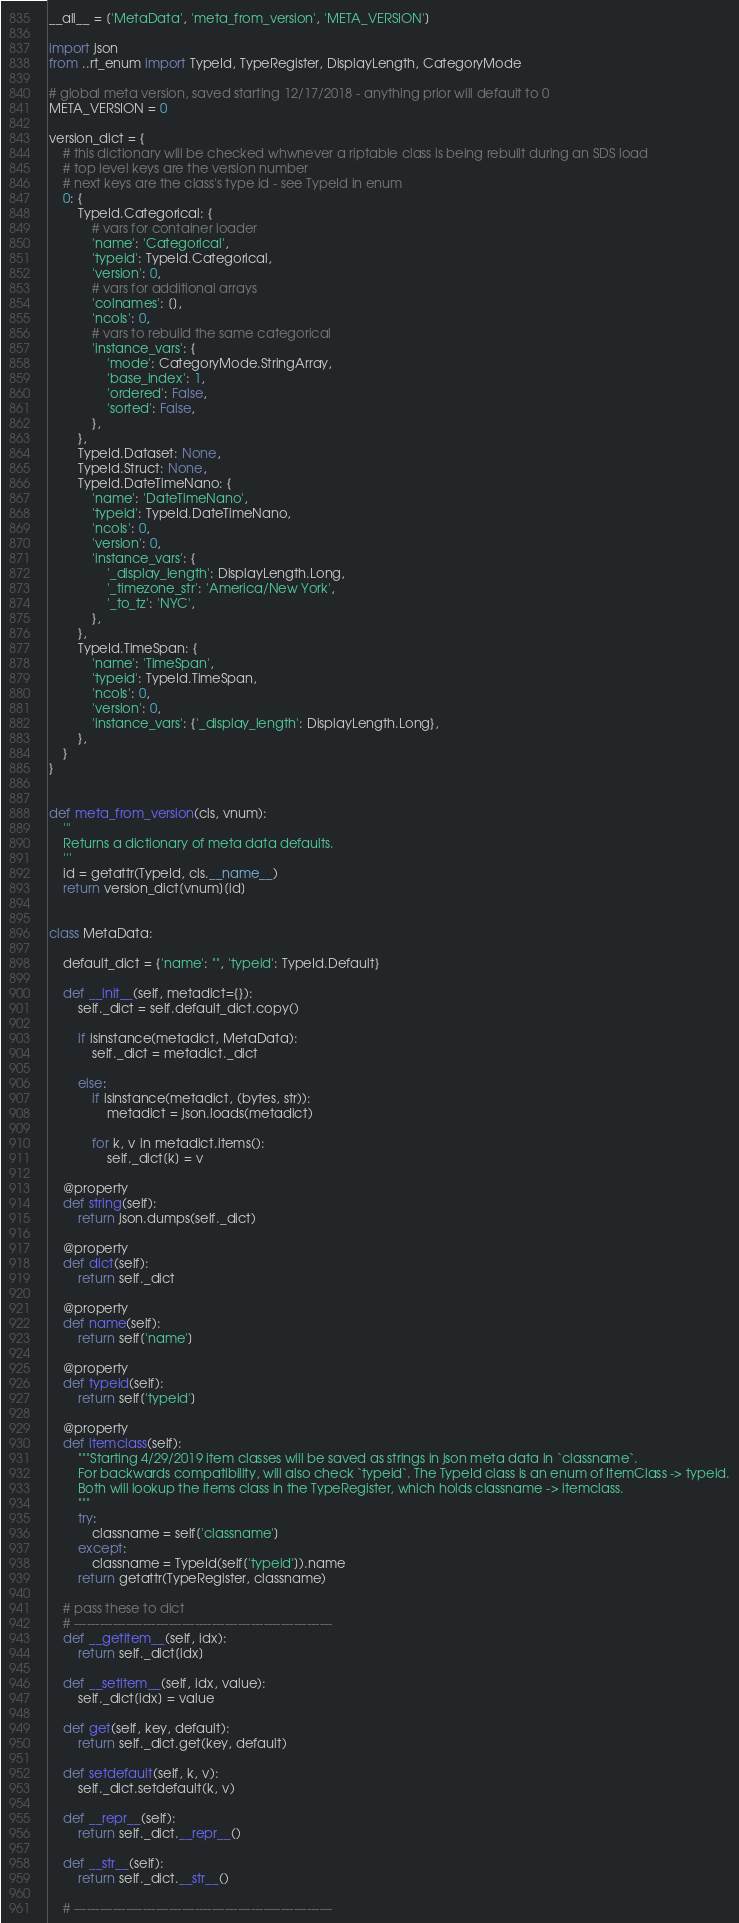<code> <loc_0><loc_0><loc_500><loc_500><_Python_>__all__ = ['MetaData', 'meta_from_version', 'META_VERSION']

import json
from ..rt_enum import TypeId, TypeRegister, DisplayLength, CategoryMode

# global meta version, saved starting 12/17/2018 - anything prior will default to 0
META_VERSION = 0

version_dict = {
    # this dictionary will be checked whwnever a riptable class is being rebuilt during an SDS load
    # top level keys are the version number
    # next keys are the class's type id - see TypeId in enum
    0: {
        TypeId.Categorical: {
            # vars for container loader
            'name': 'Categorical',
            'typeid': TypeId.Categorical,
            'version': 0,
            # vars for additional arrays
            'colnames': [],
            'ncols': 0,
            # vars to rebuild the same categorical
            'instance_vars': {
                'mode': CategoryMode.StringArray,
                'base_index': 1,
                'ordered': False,
                'sorted': False,
            },
        },
        TypeId.Dataset: None,
        TypeId.Struct: None,
        TypeId.DateTimeNano: {
            'name': 'DateTimeNano',
            'typeid': TypeId.DateTimeNano,
            'ncols': 0,
            'version': 0,
            'instance_vars': {
                '_display_length': DisplayLength.Long,
                '_timezone_str': 'America/New York',
                '_to_tz': 'NYC',
            },
        },
        TypeId.TimeSpan: {
            'name': 'TimeSpan',
            'typeid': TypeId.TimeSpan,
            'ncols': 0,
            'version': 0,
            'instance_vars': {'_display_length': DisplayLength.Long},
        },
    }
}


def meta_from_version(cls, vnum):
    '''
    Returns a dictionary of meta data defaults.
    '''
    id = getattr(TypeId, cls.__name__)
    return version_dict[vnum][id]


class MetaData:

    default_dict = {'name': "", 'typeid': TypeId.Default}

    def __init__(self, metadict={}):
        self._dict = self.default_dict.copy()

        if isinstance(metadict, MetaData):
            self._dict = metadict._dict

        else:
            if isinstance(metadict, (bytes, str)):
                metadict = json.loads(metadict)

            for k, v in metadict.items():
                self._dict[k] = v

    @property
    def string(self):
        return json.dumps(self._dict)

    @property
    def dict(self):
        return self._dict

    @property
    def name(self):
        return self['name']

    @property
    def typeid(self):
        return self['typeid']

    @property
    def itemclass(self):
        """Starting 4/29/2019 item classes will be saved as strings in json meta data in `classname`.
        For backwards compatibility, will also check `typeid`. The TypeId class is an enum of ItemClass -> typeid.
        Both will lookup the items class in the TypeRegister, which holds classname -> itemclass.
        """
        try:
            classname = self['classname']
        except:
            classname = TypeId(self['typeid']).name
        return getattr(TypeRegister, classname)

    # pass these to dict
    # ------------------------------------------------------------
    def __getitem__(self, idx):
        return self._dict[idx]

    def __setitem__(self, idx, value):
        self._dict[idx] = value

    def get(self, key, default):
        return self._dict.get(key, default)

    def setdefault(self, k, v):
        self._dict.setdefault(k, v)

    def __repr__(self):
        return self._dict.__repr__()

    def __str__(self):
        return self._dict.__str__()

    # ------------------------------------------------------------
</code> 